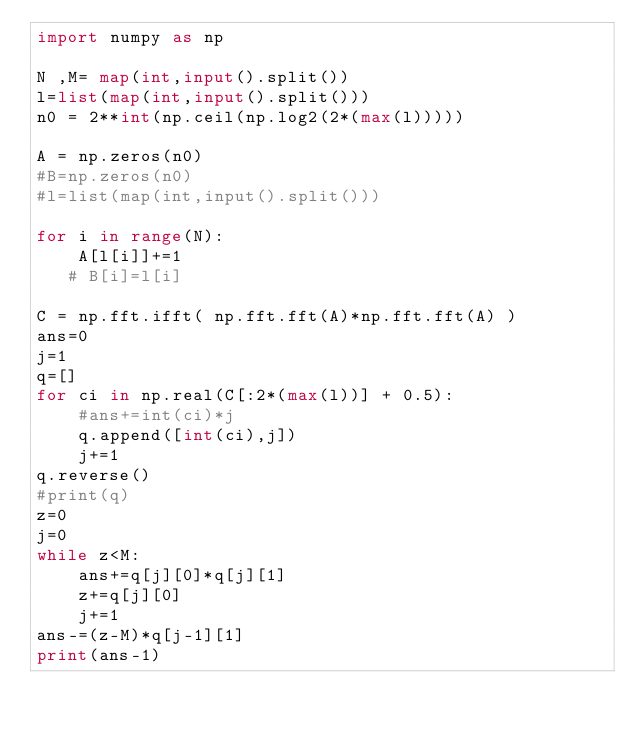Convert code to text. <code><loc_0><loc_0><loc_500><loc_500><_Python_>import numpy as np

N ,M= map(int,input().split())
l=list(map(int,input().split()))
n0 = 2**int(np.ceil(np.log2(2*(max(l)))))

A = np.zeros(n0)
#B=np.zeros(n0)
#l=list(map(int,input().split()))

for i in range(N):
    A[l[i]]+=1
   # B[i]=l[i]

C = np.fft.ifft( np.fft.fft(A)*np.fft.fft(A) )
ans=0
j=1
q=[]
for ci in np.real(C[:2*(max(l))] + 0.5):
    #ans+=int(ci)*j
    q.append([int(ci),j])
    j+=1
q.reverse()
#print(q)
z=0
j=0
while z<M:
    ans+=q[j][0]*q[j][1]
    z+=q[j][0]
    j+=1
ans-=(z-M)*q[j-1][1]
print(ans-1)

</code> 